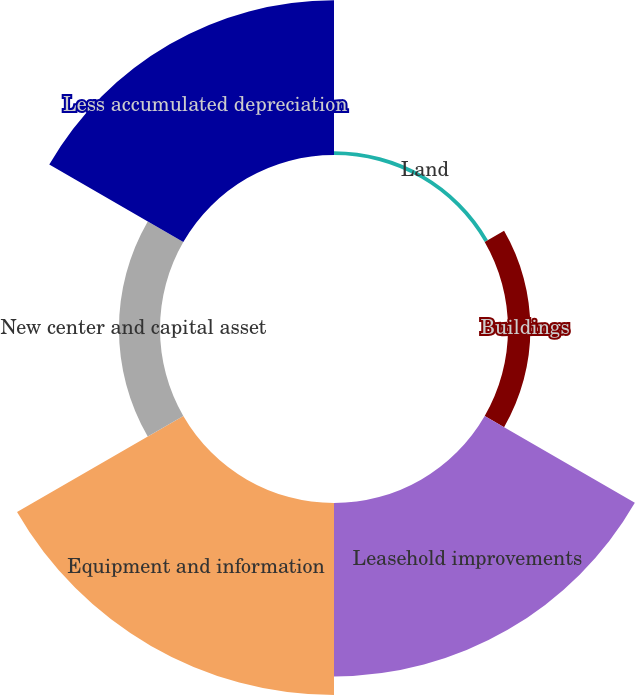Convert chart. <chart><loc_0><loc_0><loc_500><loc_500><pie_chart><fcel>Land<fcel>Buildings<fcel>Leasehold improvements<fcel>Equipment and information<fcel>New center and capital asset<fcel>Less accumulated depreciation<nl><fcel>0.64%<fcel>3.81%<fcel>29.52%<fcel>32.69%<fcel>6.99%<fcel>26.35%<nl></chart> 